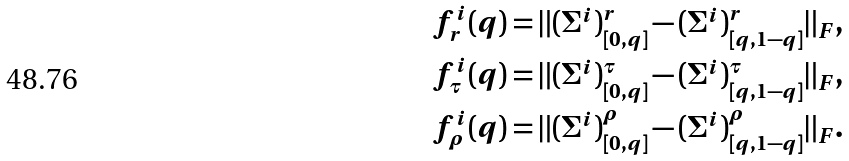<formula> <loc_0><loc_0><loc_500><loc_500>f ^ { i } _ { r } ( q ) & = \| ( \Sigma ^ { i } ) ^ { r } _ { [ 0 , q ] } - ( \Sigma ^ { i } ) ^ { r } _ { [ q , 1 - q ] } \| _ { F } , \\ f ^ { i } _ { \tau } ( q ) & = \| ( \Sigma ^ { i } ) ^ { \tau } _ { [ 0 , q ] } - ( \Sigma ^ { i } ) ^ { \tau } _ { [ q , 1 - q ] } \| _ { F } , \\ f ^ { i } _ { \rho } ( q ) & = \| ( \Sigma ^ { i } ) ^ { \rho } _ { [ 0 , q ] } - ( \Sigma ^ { i } ) ^ { \rho } _ { [ q , 1 - q ] } \| _ { F } .</formula> 